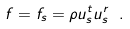Convert formula to latex. <formula><loc_0><loc_0><loc_500><loc_500>f = f _ { s } = \rho u _ { s } ^ { t } u _ { s } ^ { r } \ .</formula> 